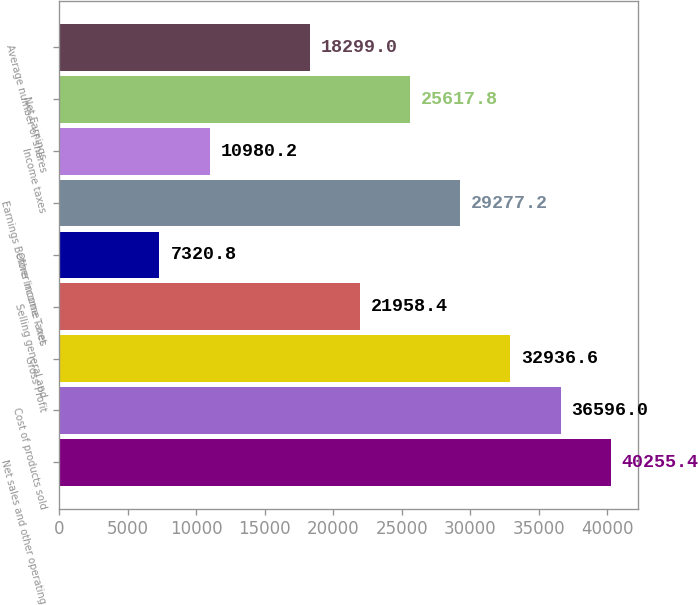Convert chart to OTSL. <chart><loc_0><loc_0><loc_500><loc_500><bar_chart><fcel>Net sales and other operating<fcel>Cost of products sold<fcel>Gross Profit<fcel>Selling general and<fcel>Other income - net<fcel>Earnings Before Income Taxes<fcel>Income taxes<fcel>Net Earnings<fcel>Average number of shares<nl><fcel>40255.4<fcel>36596<fcel>32936.6<fcel>21958.4<fcel>7320.8<fcel>29277.2<fcel>10980.2<fcel>25617.8<fcel>18299<nl></chart> 